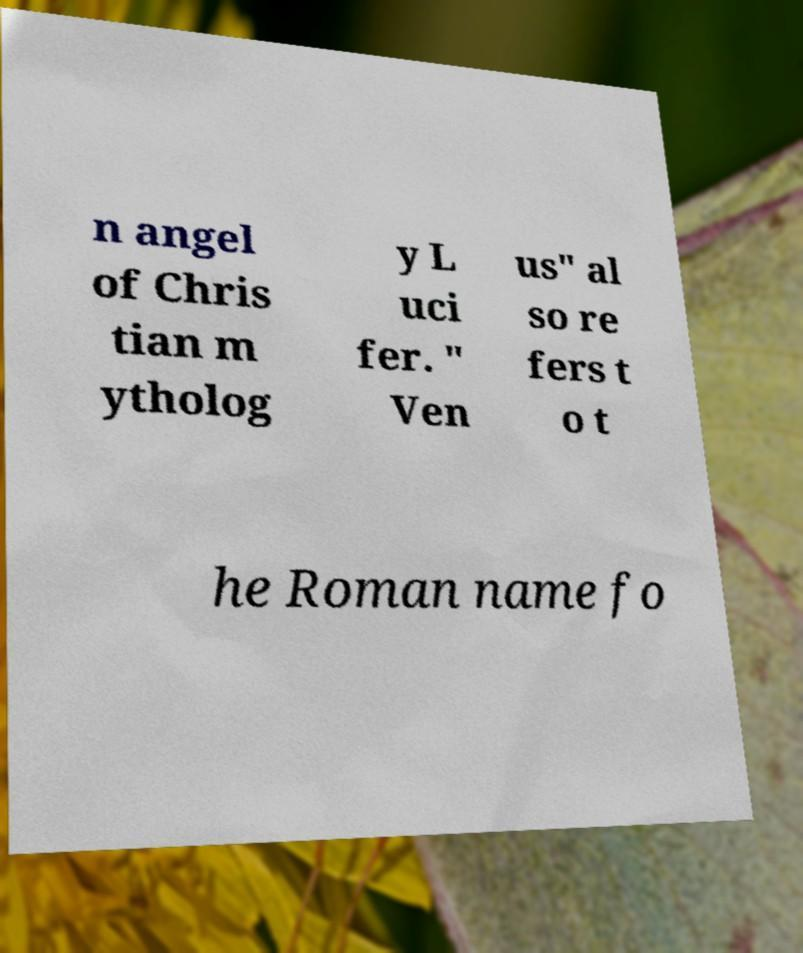For documentation purposes, I need the text within this image transcribed. Could you provide that? n angel of Chris tian m ytholog y L uci fer. " Ven us" al so re fers t o t he Roman name fo 